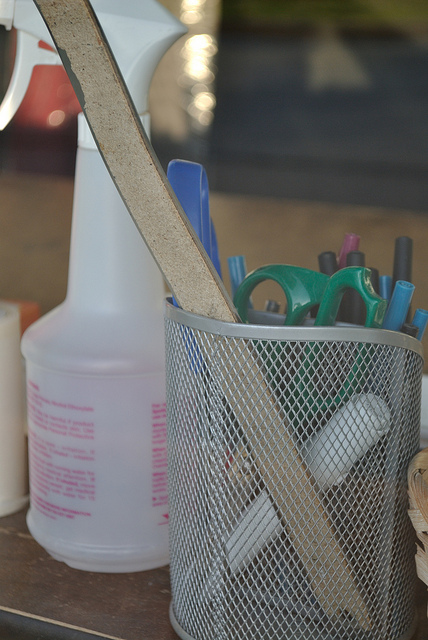<image>What type of beverage was in the bottle in the back? I don't know what type of beverage was in the bottle in the back. It could be water or cleaner. What type of beverage was in the bottle in the back? I am not sure what type of beverage was in the bottle in the back. It can be seen as water or cleaner. 